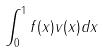Convert formula to latex. <formula><loc_0><loc_0><loc_500><loc_500>\int _ { 0 } ^ { 1 } f ( x ) v ( x ) d x</formula> 